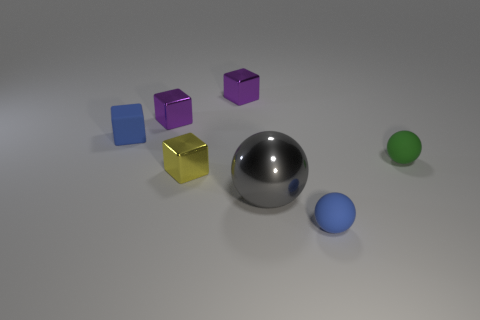Add 1 large gray spheres. How many objects exist? 8 Subtract all balls. How many objects are left? 4 Subtract 1 blue blocks. How many objects are left? 6 Subtract all metal balls. Subtract all gray cylinders. How many objects are left? 6 Add 1 purple shiny objects. How many purple shiny objects are left? 3 Add 7 small matte cubes. How many small matte cubes exist? 8 